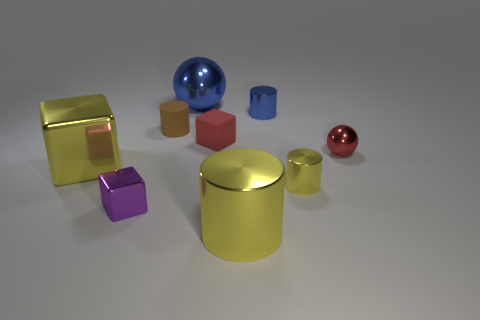There is a small purple metal object; is it the same shape as the small red thing on the left side of the red shiny thing?
Your response must be concise. Yes. There is a metallic thing that is both in front of the big shiny block and to the left of the large metallic cylinder; how big is it?
Your response must be concise. Small. Are there any blue balls that have the same material as the small yellow cylinder?
Your answer should be very brief. Yes. There is a shiny object that is the same color as the rubber cube; what size is it?
Your answer should be very brief. Small. What material is the sphere in front of the large object behind the red ball?
Provide a short and direct response. Metal. What number of big rubber cylinders are the same color as the big cube?
Give a very brief answer. 0. There is a purple cube that is the same material as the small blue cylinder; what is its size?
Provide a succinct answer. Small. What shape is the large yellow object behind the small yellow thing?
Provide a short and direct response. Cube. What is the size of the blue metallic object that is the same shape as the tiny yellow thing?
Ensure brevity in your answer.  Small. What number of red matte objects are behind the metal sphere behind the sphere that is to the right of the large yellow cylinder?
Keep it short and to the point. 0. 